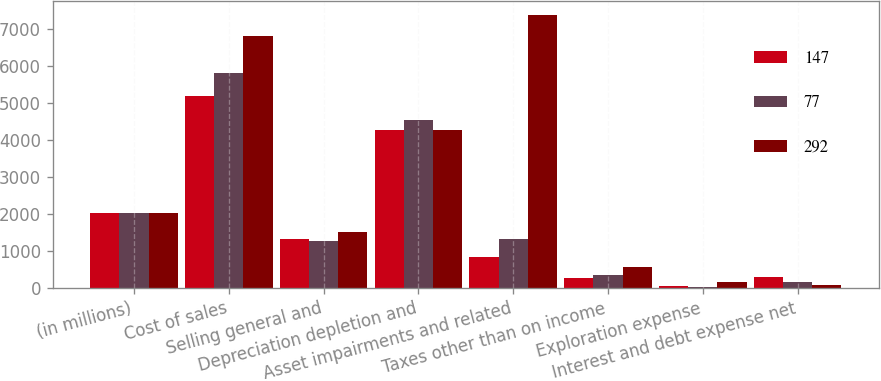Convert chart. <chart><loc_0><loc_0><loc_500><loc_500><stacked_bar_chart><ecel><fcel>(in millions)<fcel>Cost of sales<fcel>Selling general and<fcel>Depreciation depletion and<fcel>Asset impairments and related<fcel>Taxes other than on income<fcel>Exploration expense<fcel>Interest and debt expense net<nl><fcel>147<fcel>2016<fcel>5189<fcel>1330<fcel>4268<fcel>825<fcel>277<fcel>62<fcel>292<nl><fcel>77<fcel>2015<fcel>5804<fcel>1270<fcel>4544<fcel>1330<fcel>343<fcel>36<fcel>147<nl><fcel>292<fcel>2014<fcel>6803<fcel>1503<fcel>4261<fcel>7379<fcel>550<fcel>150<fcel>77<nl></chart> 